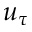<formula> <loc_0><loc_0><loc_500><loc_500>u _ { \tau }</formula> 